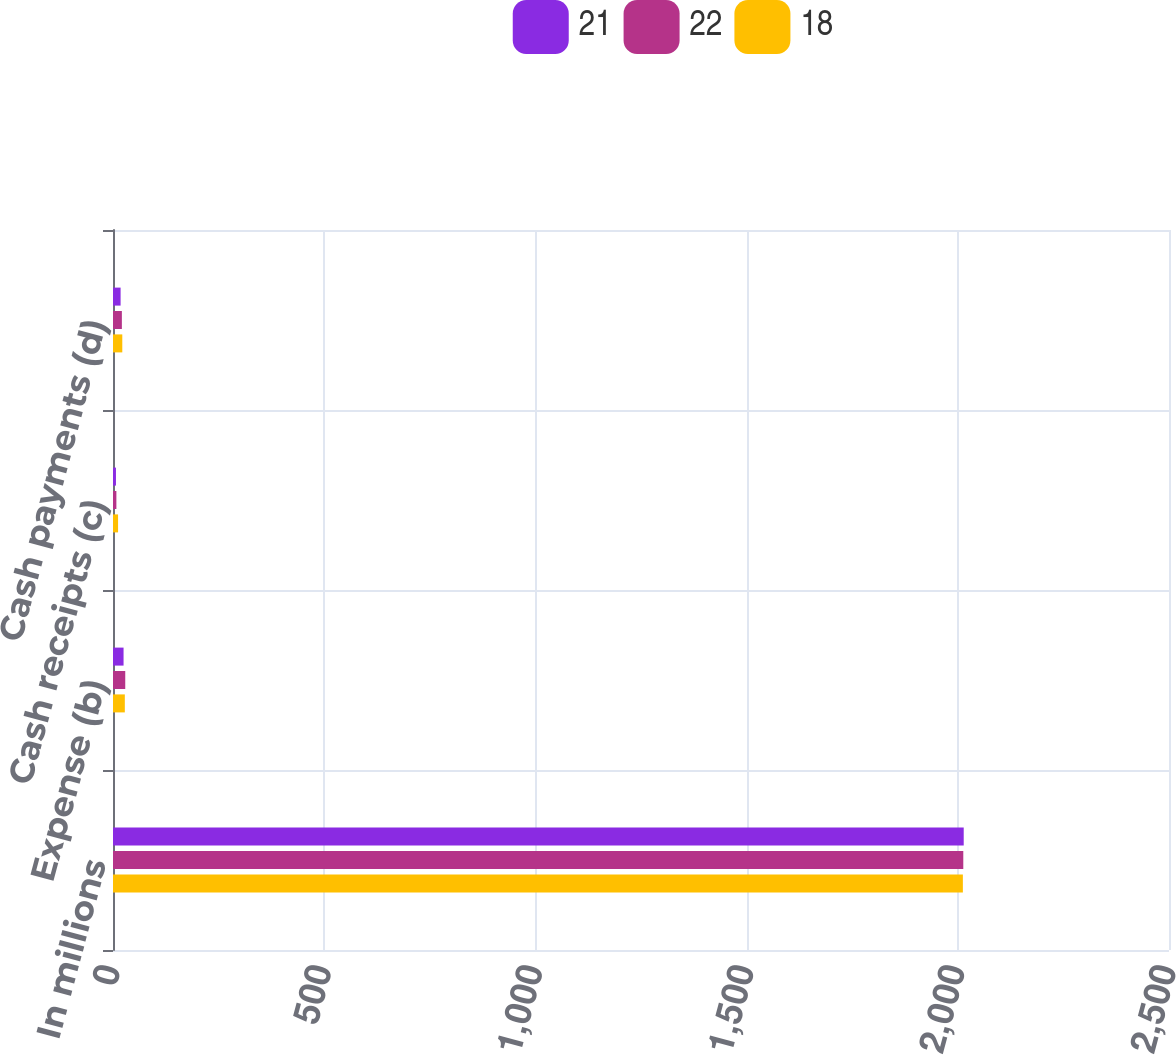<chart> <loc_0><loc_0><loc_500><loc_500><stacked_bar_chart><ecel><fcel>In millions<fcel>Expense (b)<fcel>Cash receipts (c)<fcel>Cash payments (d)<nl><fcel>21<fcel>2014<fcel>25<fcel>7<fcel>18<nl><fcel>22<fcel>2013<fcel>29<fcel>8<fcel>21<nl><fcel>18<fcel>2012<fcel>28<fcel>12<fcel>22<nl></chart> 